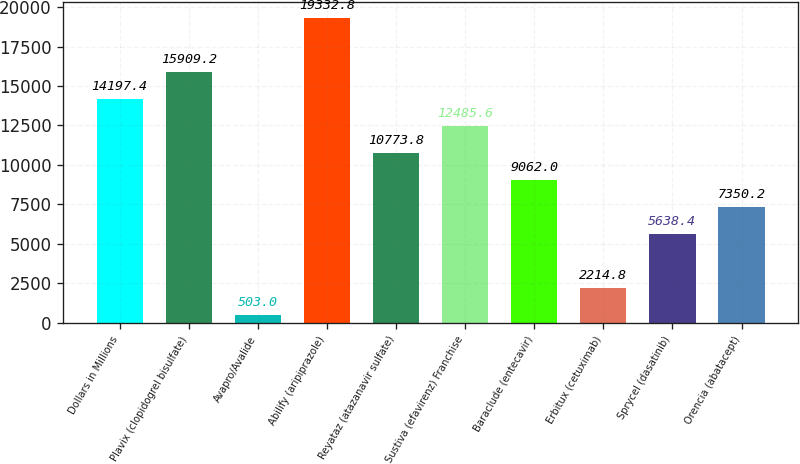Convert chart. <chart><loc_0><loc_0><loc_500><loc_500><bar_chart><fcel>Dollars in Millions<fcel>Plavix (clopidogrel bisulfate)<fcel>Avapro/Avalide<fcel>Abilify (aripiprazole)<fcel>Reyataz (atazanavir sulfate)<fcel>Sustiva (efavirenz) Franchise<fcel>Baraclude (entecavir)<fcel>Erbitux (cetuximab)<fcel>Sprycel (dasatinib)<fcel>Orencia (abatacept)<nl><fcel>14197.4<fcel>15909.2<fcel>503<fcel>19332.8<fcel>10773.8<fcel>12485.6<fcel>9062<fcel>2214.8<fcel>5638.4<fcel>7350.2<nl></chart> 